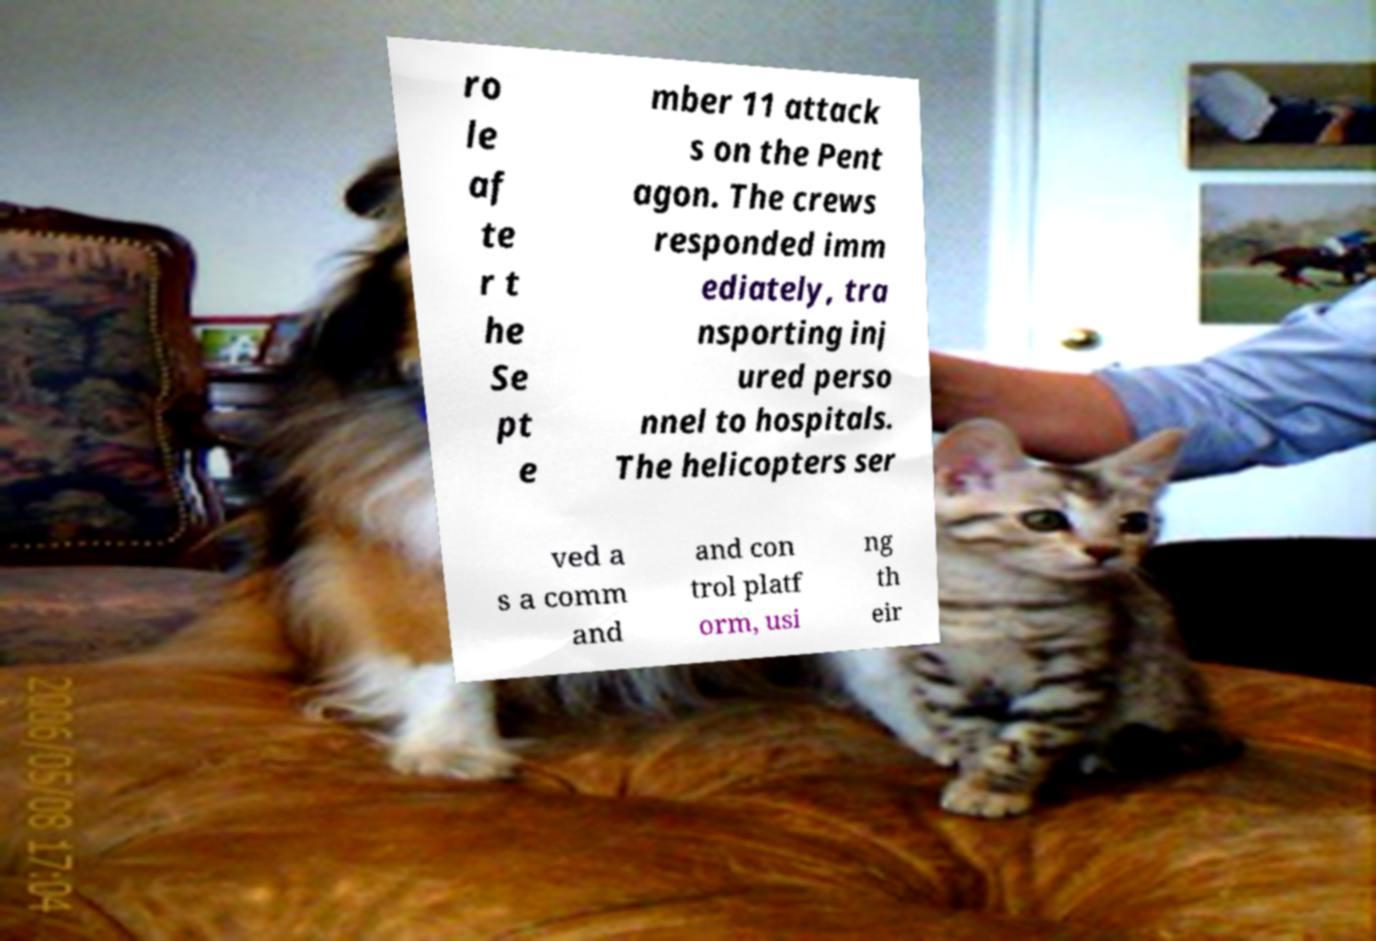Please identify and transcribe the text found in this image. ro le af te r t he Se pt e mber 11 attack s on the Pent agon. The crews responded imm ediately, tra nsporting inj ured perso nnel to hospitals. The helicopters ser ved a s a comm and and con trol platf orm, usi ng th eir 